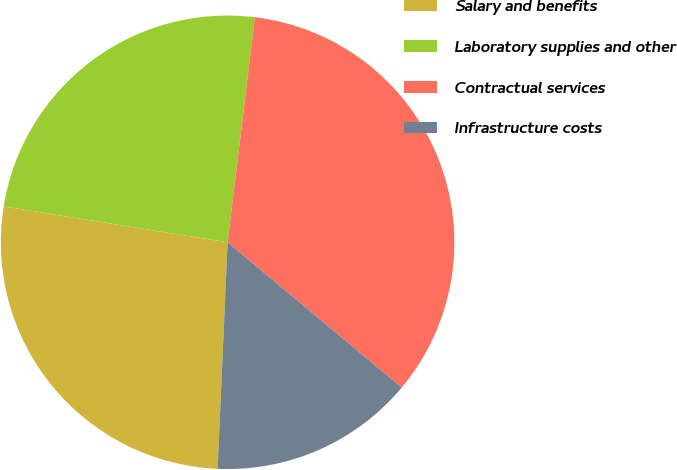<chart> <loc_0><loc_0><loc_500><loc_500><pie_chart><fcel>Salary and benefits<fcel>Laboratory supplies and other<fcel>Contractual services<fcel>Infrastructure costs<nl><fcel>26.83%<fcel>24.39%<fcel>34.15%<fcel>14.63%<nl></chart> 